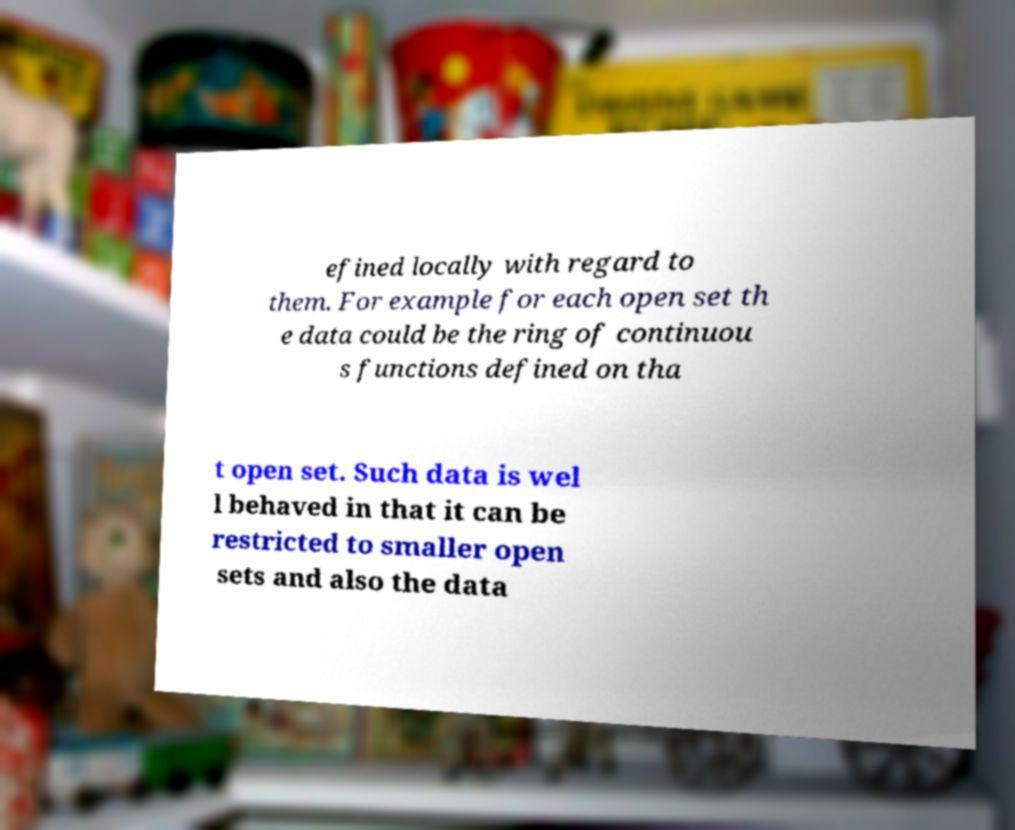I need the written content from this picture converted into text. Can you do that? efined locally with regard to them. For example for each open set th e data could be the ring of continuou s functions defined on tha t open set. Such data is wel l behaved in that it can be restricted to smaller open sets and also the data 